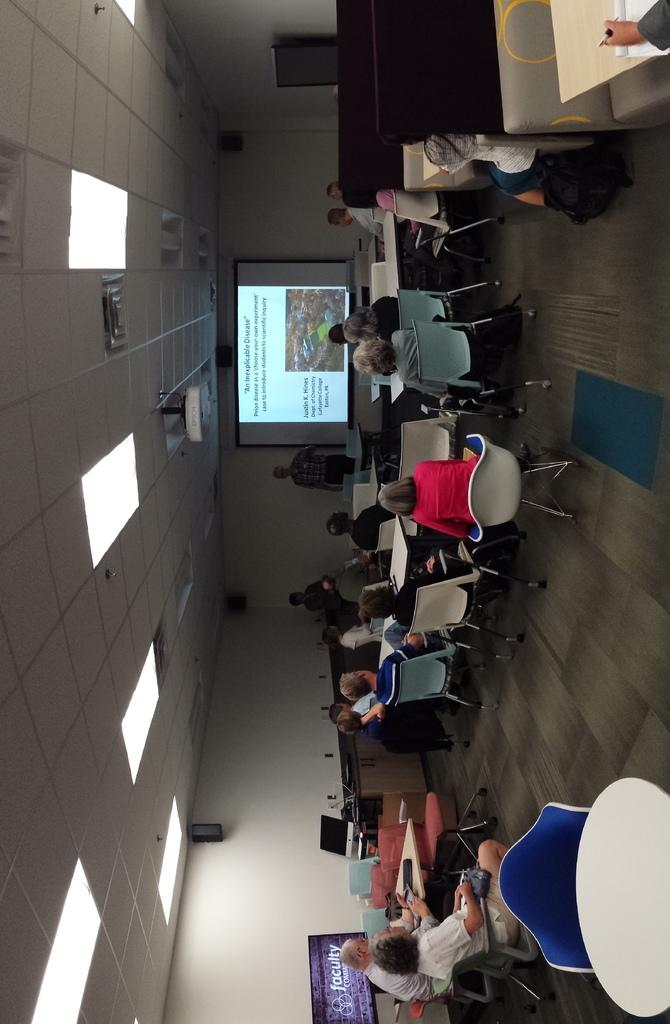<image>
Summarize the visual content of the image. A classroom full of adults are looking at a projector slide that says An Inexplicable Disease. 